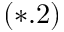Convert formula to latex. <formula><loc_0><loc_0><loc_500><loc_500>( * . 2 )</formula> 